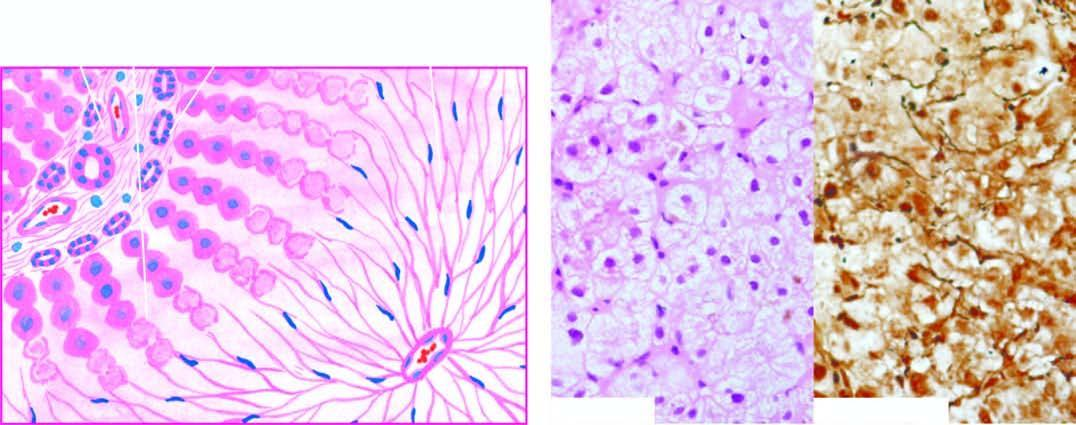s there wiping out of liver lobules with only collapsed reticulin framework left out in their place, high lighted by reticulin stain right photomicrograph?
Answer the question using a single word or phrase. Yes 